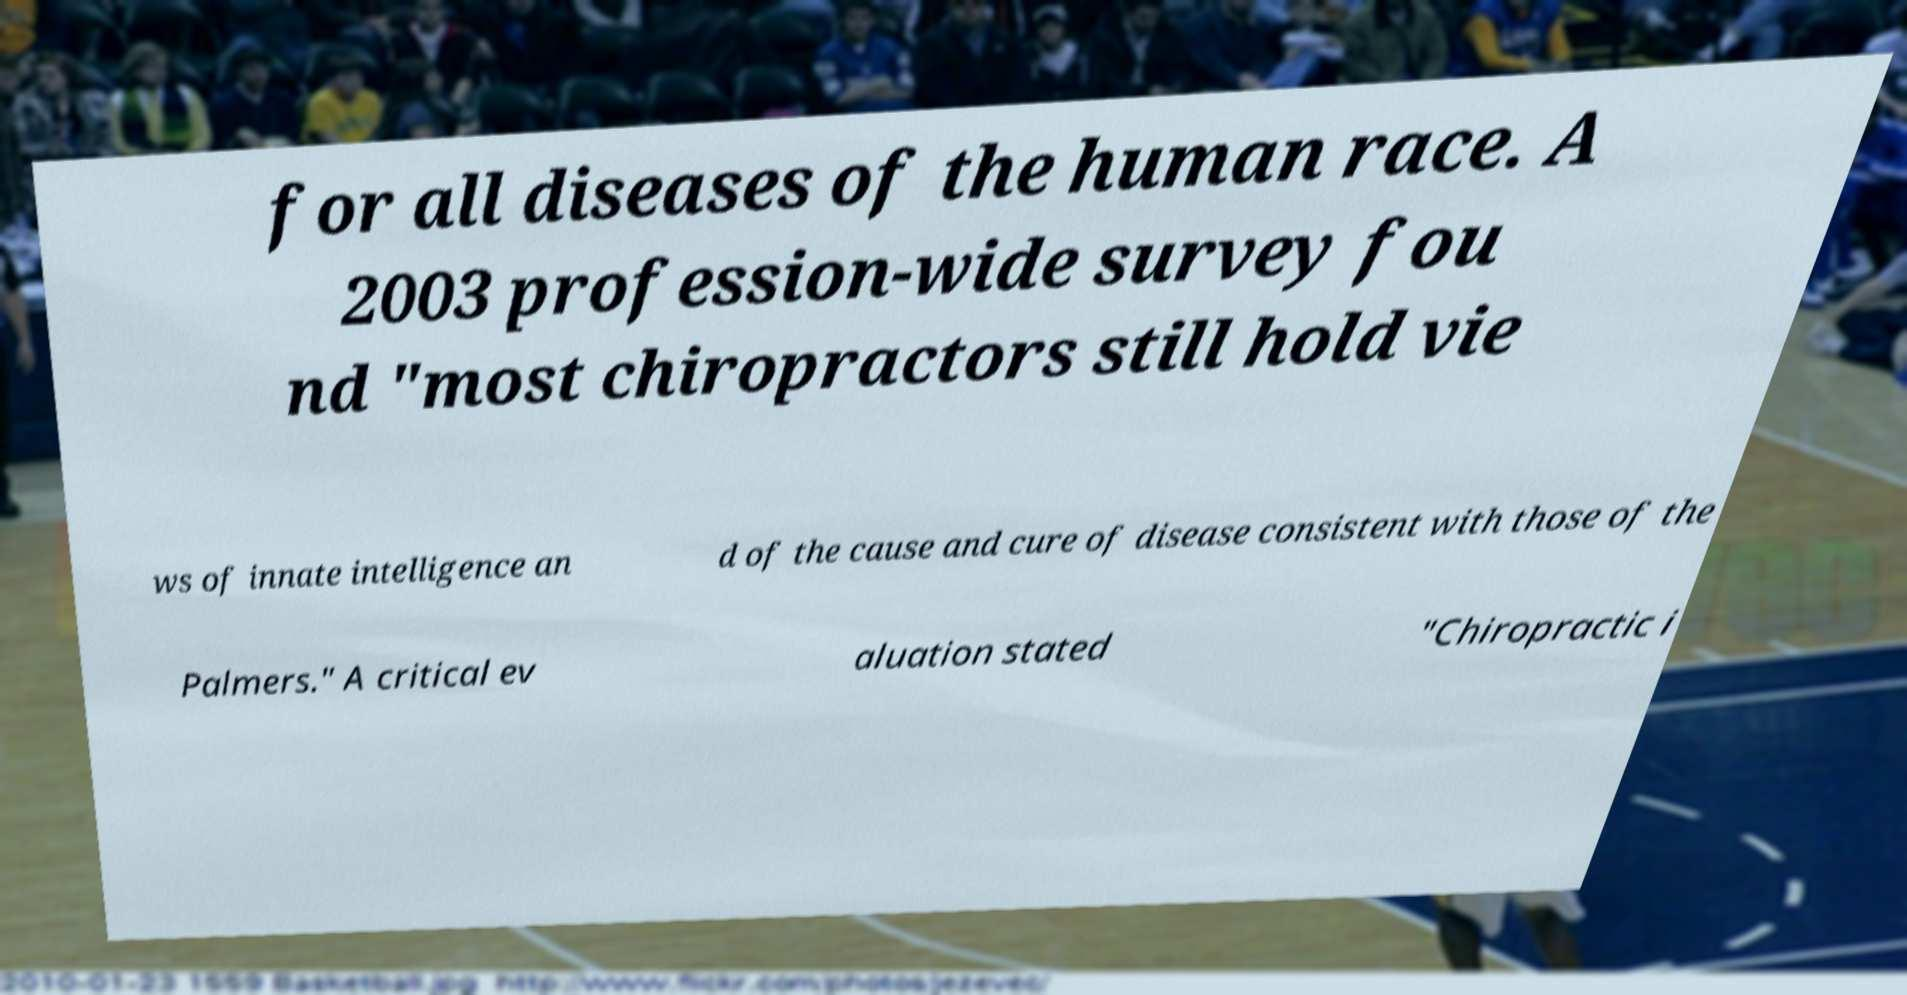Please read and relay the text visible in this image. What does it say? for all diseases of the human race. A 2003 profession-wide survey fou nd "most chiropractors still hold vie ws of innate intelligence an d of the cause and cure of disease consistent with those of the Palmers." A critical ev aluation stated "Chiropractic i 